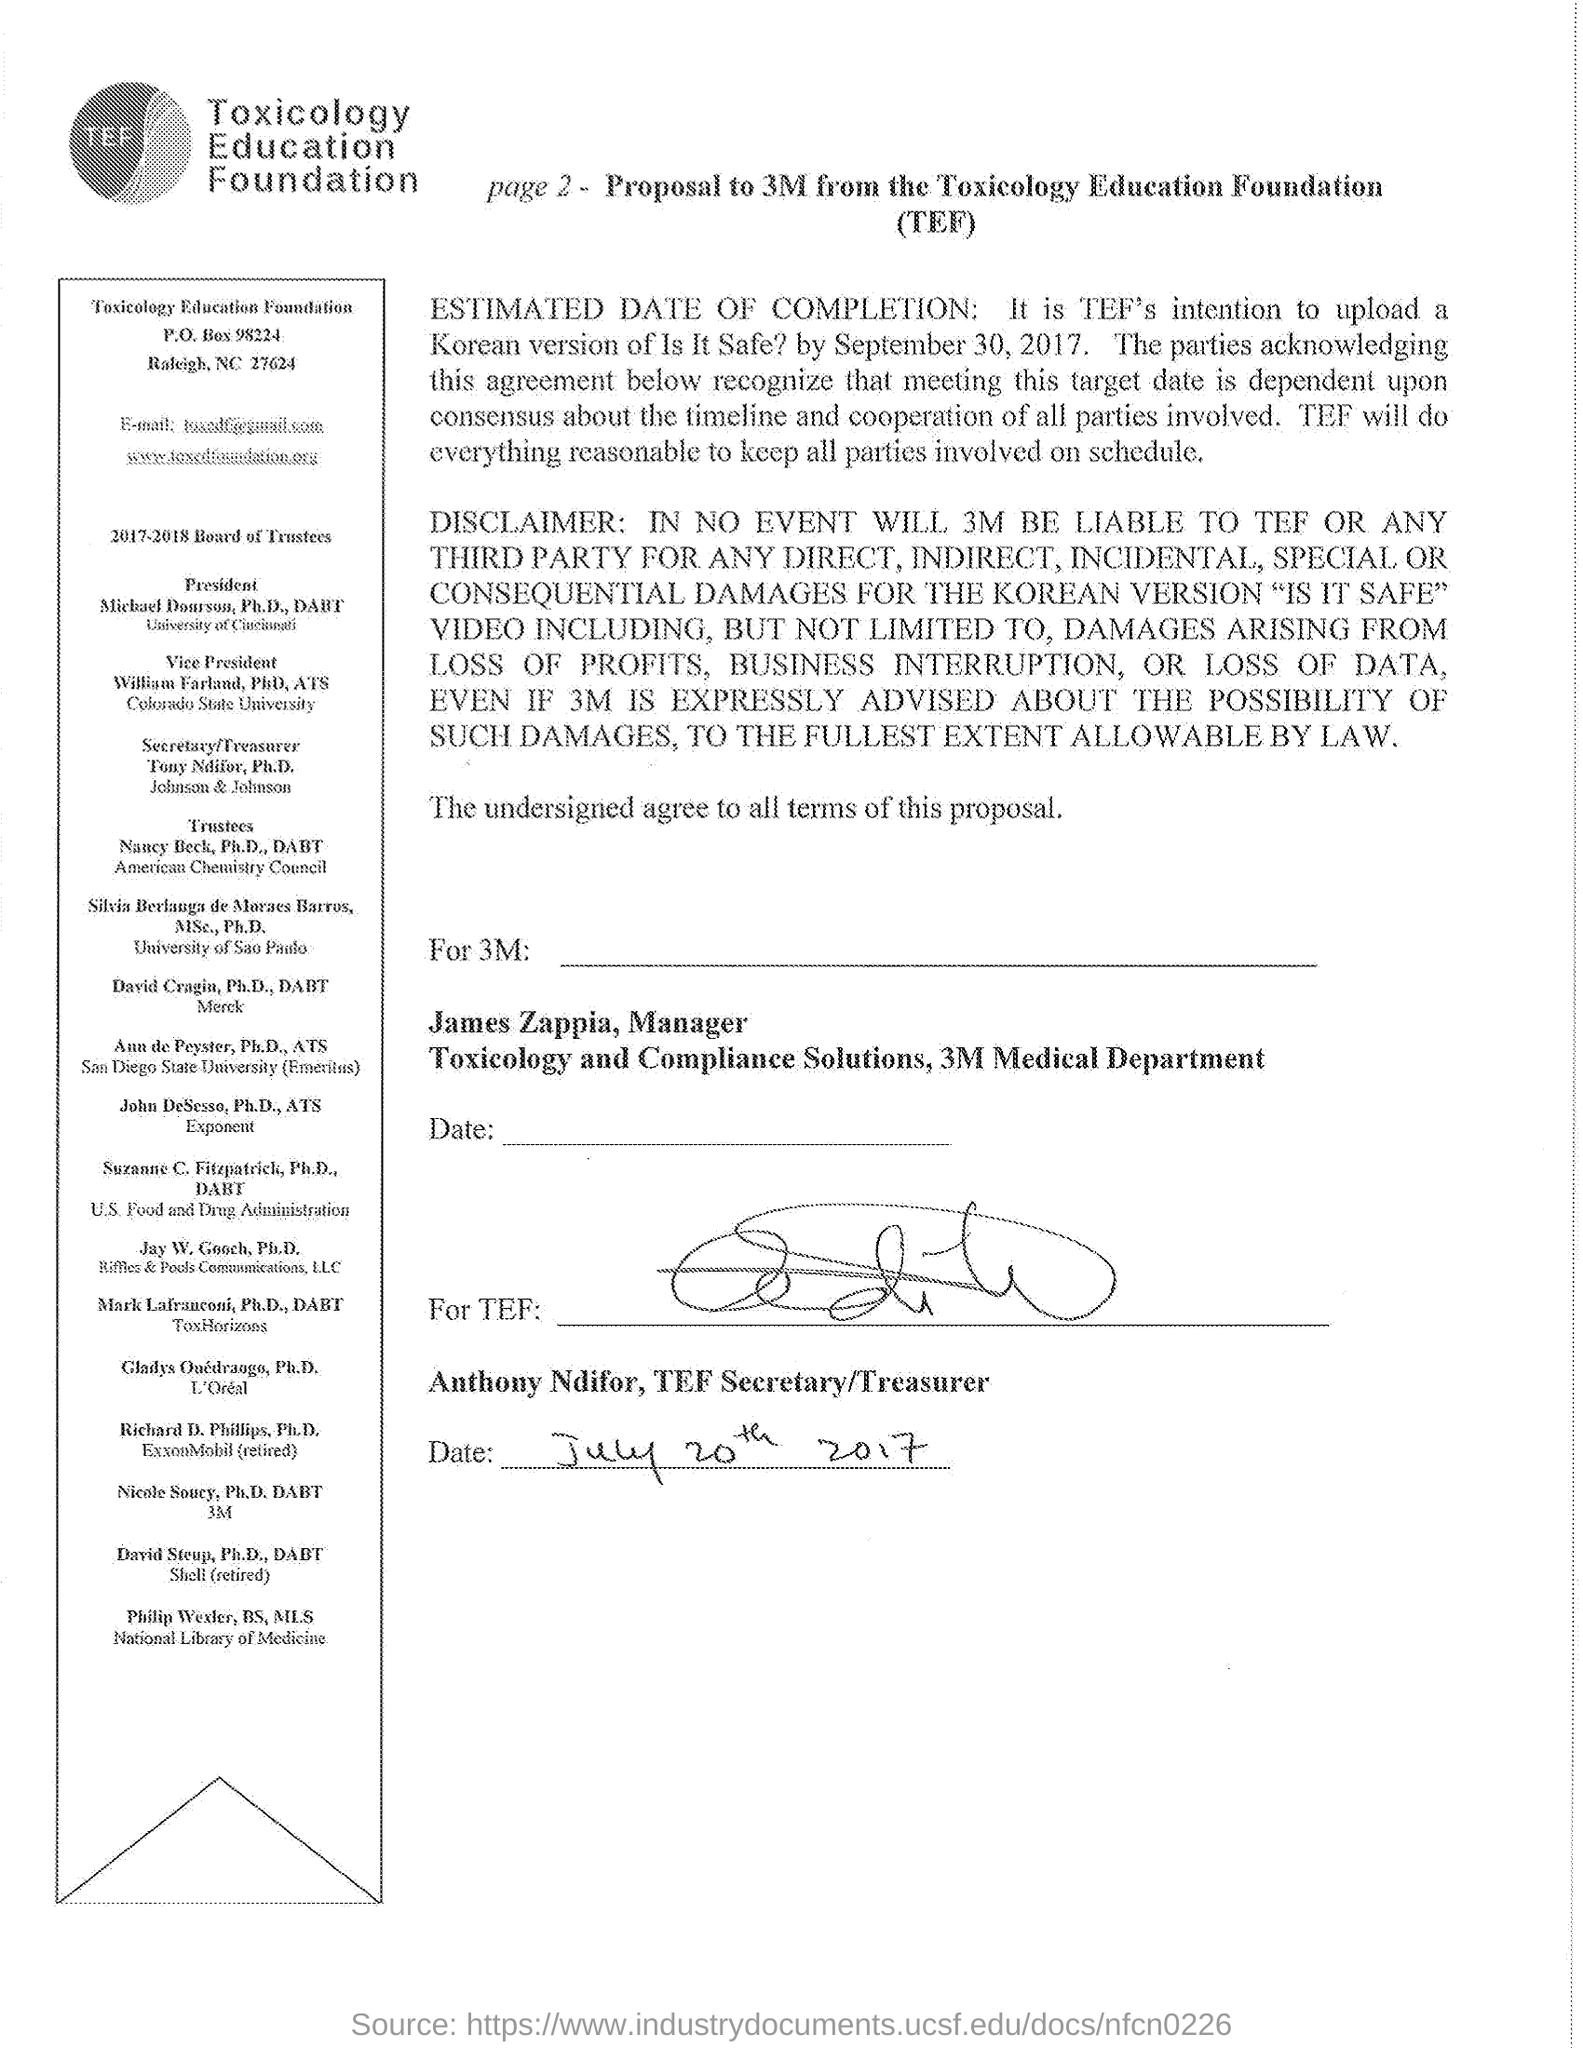Point out several critical features in this image. The vice president of the foundation is William Farland, PhD, ATS. The name of the PROPOSAL's FOUNDATION is the TOXICOLOGY EDUCATION FOUNDATION. The date mentioned at the bottom of the text is July 20th, 2017. 